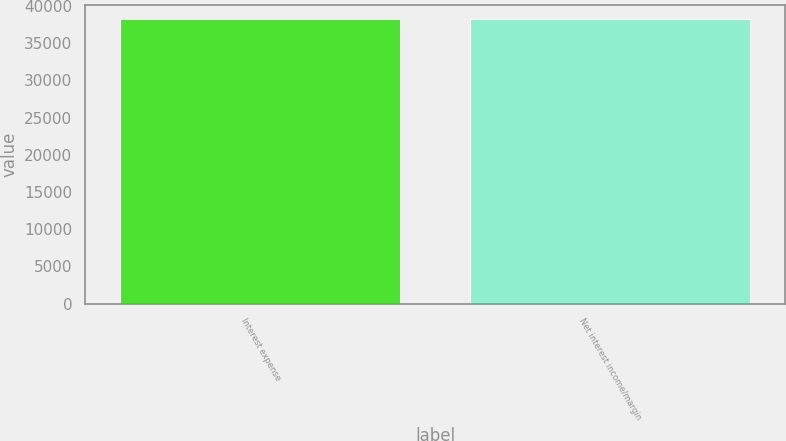Convert chart. <chart><loc_0><loc_0><loc_500><loc_500><bar_chart><fcel>Interest expense<fcel>Net interest income/margin<nl><fcel>38208<fcel>38208.1<nl></chart> 